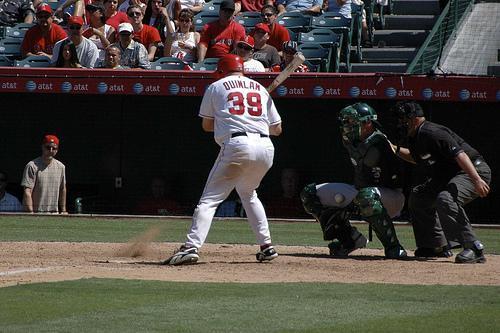How many red hats are in the scene?
Give a very brief answer. 1. 